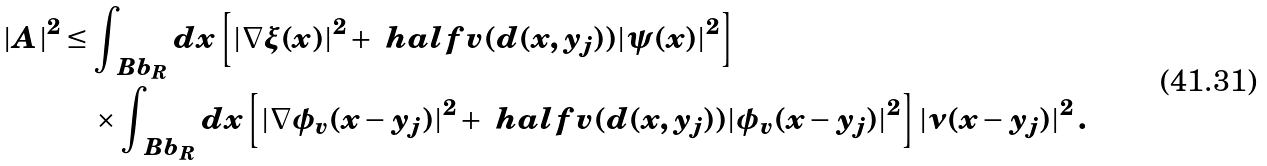<formula> <loc_0><loc_0><loc_500><loc_500>| A | ^ { 2 } & \leq \int _ { \ B b _ { R } } d x \left [ | \nabla \xi ( x ) | ^ { 2 } + \ h a l f v ( d ( x , y _ { j } ) ) | \psi ( x ) | ^ { 2 } \right ] \\ & \quad \times \int _ { \ B b _ { R } } d x \left [ | \nabla \phi _ { v } ( x - y _ { j } ) | ^ { 2 } + \ h a l f v ( d ( x , y _ { j } ) ) | \phi _ { v } ( x - y _ { j } ) | ^ { 2 } \right ] | \nu ( x - y _ { j } ) | ^ { 2 } \, .</formula> 